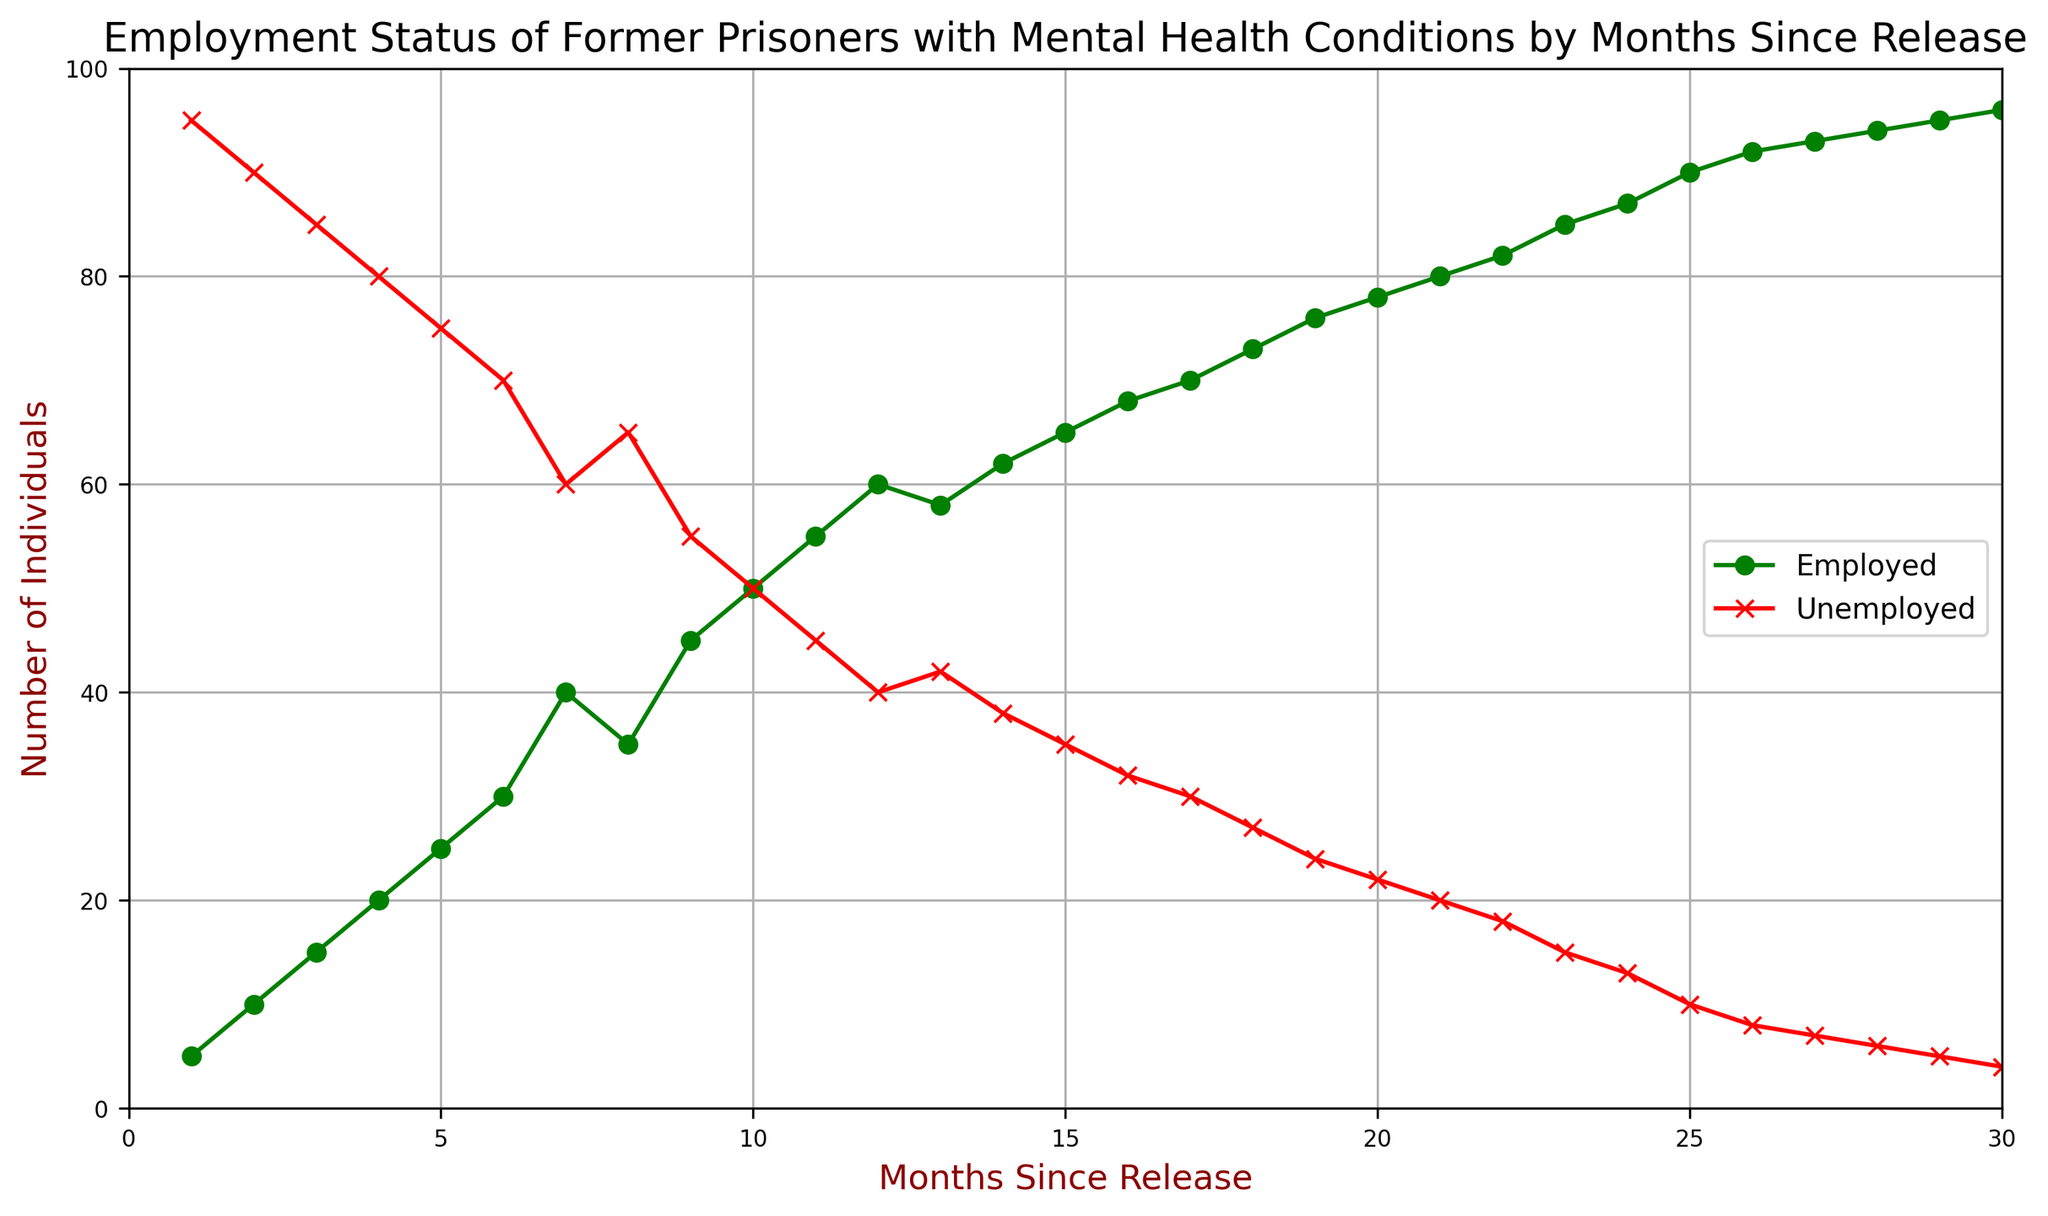What is the number of employed individuals at 10 months since release? From looking at the plot, identify the point where "Months Since Release" is 10 on the x-axis and read off the corresponding value on the "Employment Status (Employed)" line.
Answer: 50 Which month shows the first instance of 50 or more employed individuals? Identify the point on the "Employment Status (Employed)" line where the y-value first reaches 50 or more. This occurs at the 10th month.
Answer: 10 What is the difference in the number of employed individuals between the 15th and 10th month since release? At the 15th month, the number of employed individuals is 65, and at the 10th month, it is 50. Calculate the difference as 65 - 50.
Answer: 15 By how many individuals does the unemployment rate decrease between the 1st and 24th month since release? At the 1st month, the number of unemployed individuals is 95, and at the 24th month, it is 13. Calculate the decrease as 95 - 13.
Answer: 82 Which month has the highest number of unemployed individuals, and what is that number? Locate the peak on the "Employment Status (Unemployed)" line and read the corresponding month and value. The peak occurs at the 1st month with 95 unemployed individuals.
Answer: 1, 95 How many months since release does it take for the number of employed individuals to exceed 70? Identify the month where the "Employment Status (Employed)" line crosses 70 for the first time, which is at the 17th month.
Answer: 17 What is the average number of employed individuals over the first 5 months since release? Identify the employed values for the first 5 months (5, 10, 15, 20, 25). Sum these values and divide by 5: (5 + 10 + 15 + 20 + 25)/5 = 75/5 = 15.
Answer: 15 Compare the number of employed and unemployed individuals at the 20th month since release. Which is higher, and by how much? At the 20th month, the number of employed individuals is 78 and the number of unemployed individuals is 22. The difference is 78 - 22.
Answer: Employed, 56 What overall trend in employment status can be observed from the first to the last month in the dataset? Observe that the employment status shows an increasing trend from 5 to 96, while the unemployment status shows a decreasing trend from 95 to 4 over the 30-month period.
Answer: Employment increases, Unemployment decreases What is the median number of unemployed individuals over the 30-month period? List the unemployed values over the 30 months and find the middle value, which in an even number of data points is the average of the 15th and 16th data point values (35 and 32). The median is (35 + 32)/2 = 33.5.
Answer: 33.5 